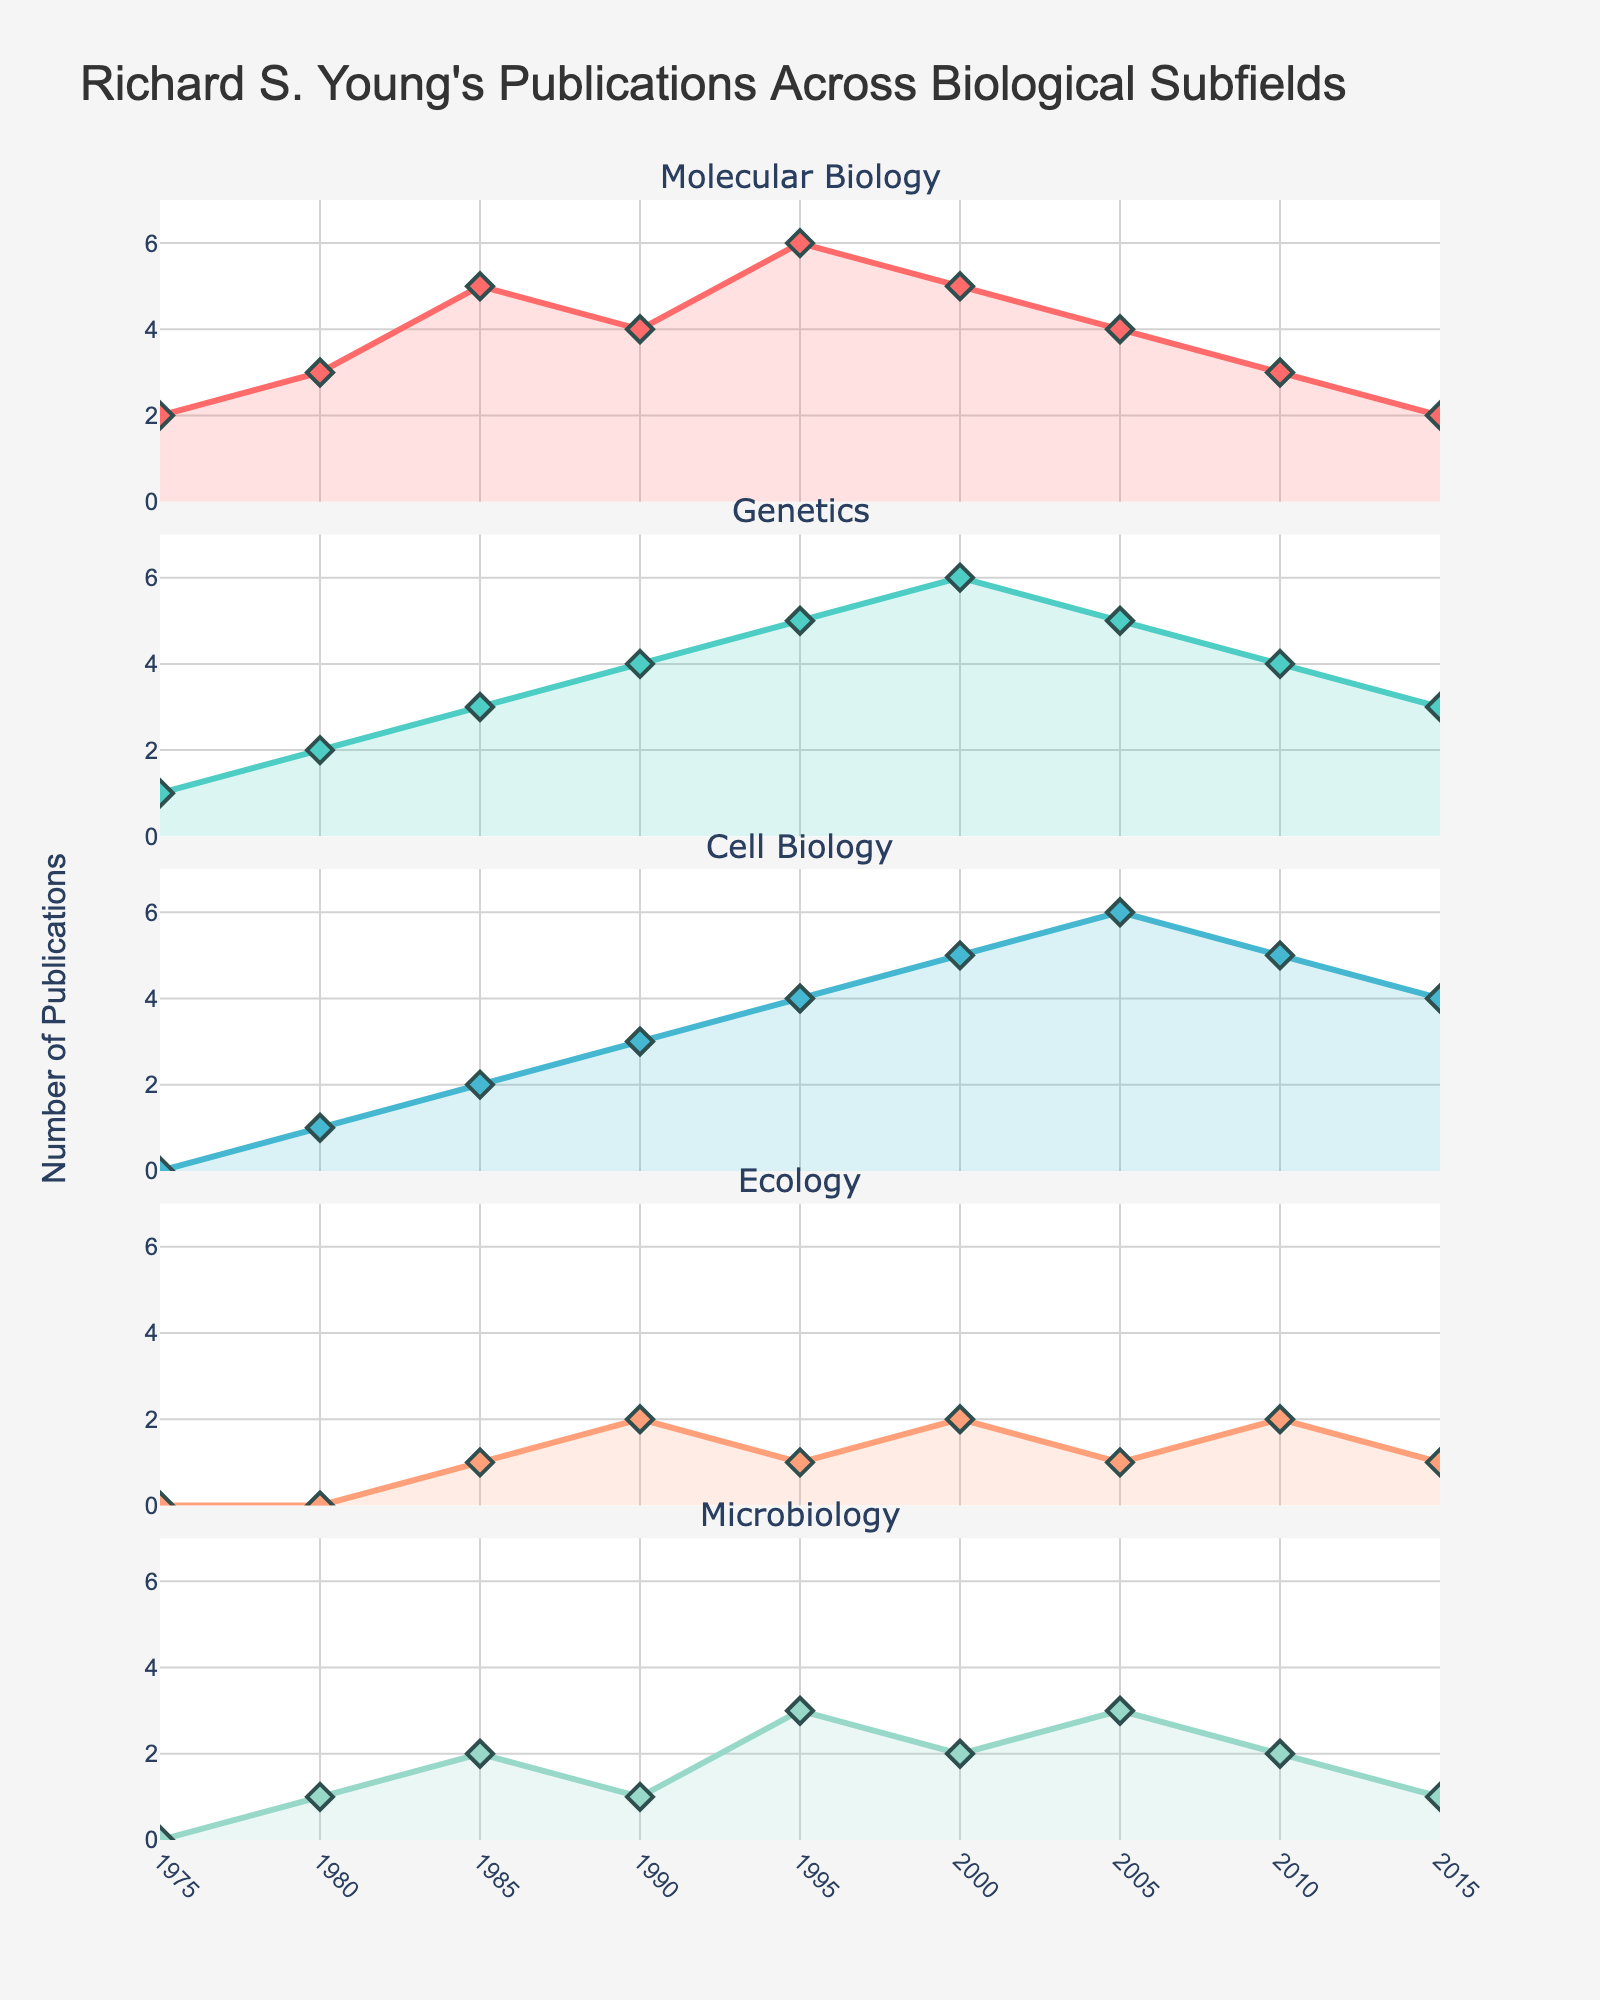What is the main title of the entire figure? The main title can be found at the top of the figure. It indicates the subject or purpose of the plot.
Answer: Richard S. Young's Publications Across Biological Subfields What subfield saw the highest number of publications in 1995? Look at the 1995 data and compare the values for Molecular Biology, Genetics, Cell Biology, Ecology, and Microbiology. Molecular Biology has the highest number of publications with 6.
Answer: Molecular Biology How did the number of publications in Ecology change from 1985 to 1990? Check the values for Ecology in 1985 and 1990. In 1985, the number was 1, and in 1990, it increased to 2, showing an increase of 1 publication.
Answer: Increased by 1 Which subfield has the least variability in publication numbers over the years? Observe the graphs for each subfield and note the consistency of the numbers over the years. Ecology stays between 0 and 2 publications, indicating the least variability.
Answer: Ecology Was there any year where Cell Biology publications outnumbered those in Genetics? Compare the Cell Biology and Genetics values for each year to see if there was any year where Cell Biology had higher numbers. In 2005, Cell Biology had 6 publications, more than Genetics' 5.
Answer: 2005 Calculate the total number of publications in 1980 across all subfields. Sum the values for all subfields in 1980: 3 (Molecular Biology) + 2 (Genetics) + 1 (Cell Biology) + 0 (Ecology) + 1 (Microbiology) = 7.
Answer: 7 In which year did Molecular Biology and Genetics have the same number of publications? Look for a year where the values for Molecular Biology and Genetics are equal. This happened in 1990, where both had 4 publications each.
Answer: 1990 How many more publications did Microbiology have in 2000 compared to 1975? Subtract the number of Microbiology publications in 1975 from the number in 2000: 2 - 0 = 2.
Answer: 2 Identify the subfield with the highest peak of publications over the years. Examine each subfield and find the highest single data point for each. Molecular Biology peaked at 6 publications in 1995.
Answer: Molecular Biology In which year did Richard S. Young publish the most in Microbiology? Look at the year-wise data for Microbiology to find the maximum value. The year with the highest number of Microbiology publications is 1995 with 3.
Answer: 1995 